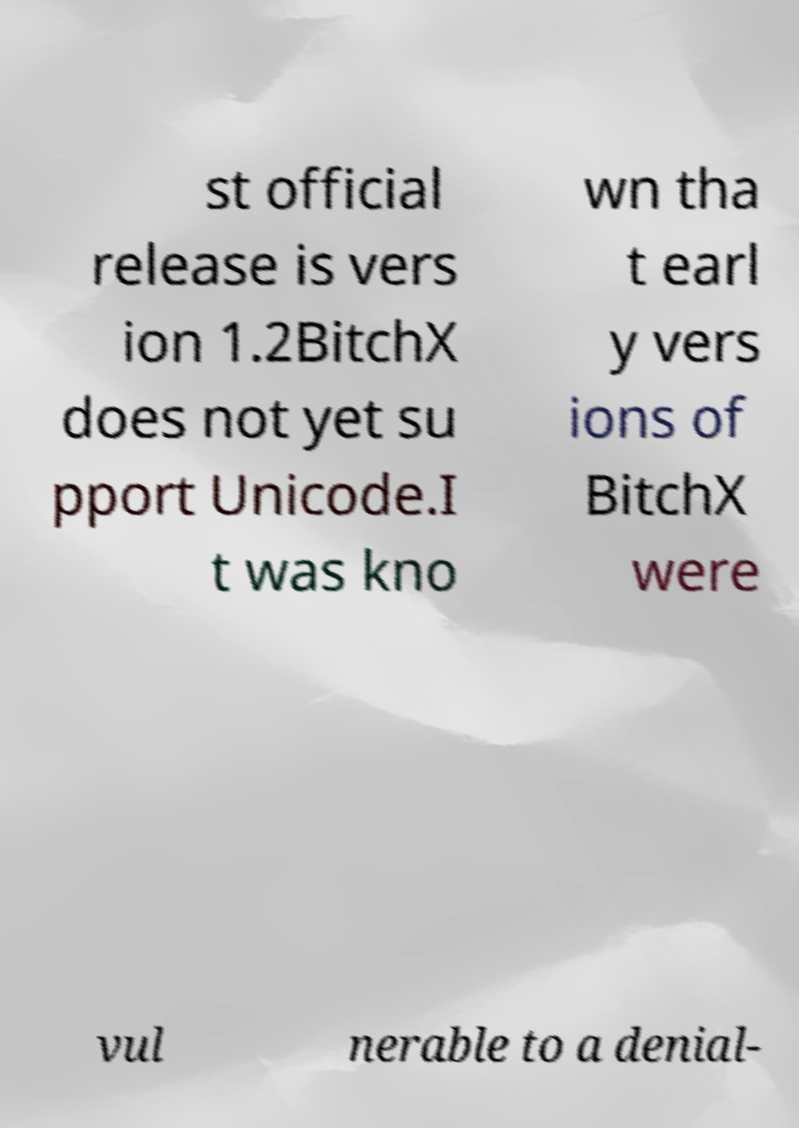Please identify and transcribe the text found in this image. st official release is vers ion 1.2BitchX does not yet su pport Unicode.I t was kno wn tha t earl y vers ions of BitchX were vul nerable to a denial- 